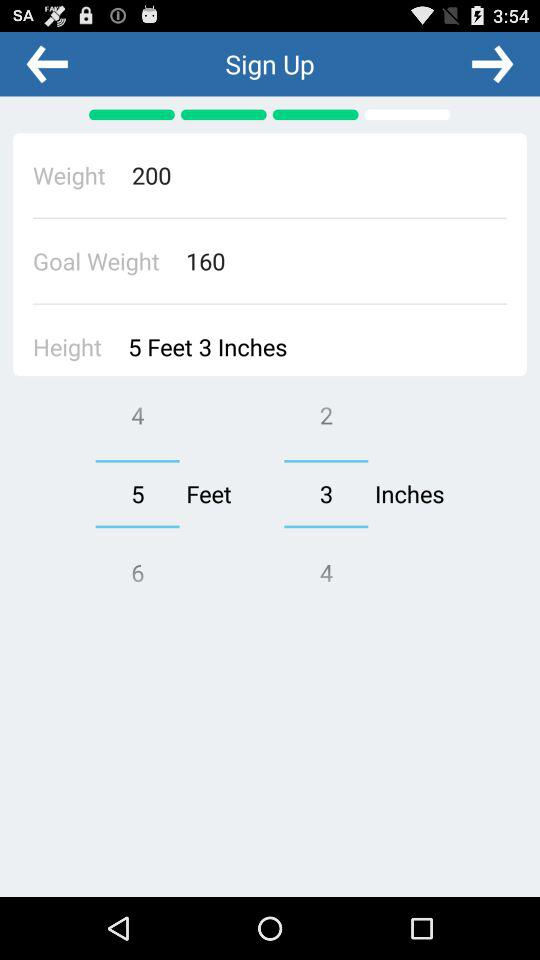What is the height? The height is 5 feet 3 inches. 